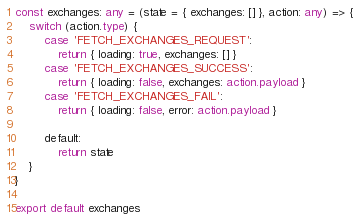Convert code to text. <code><loc_0><loc_0><loc_500><loc_500><_TypeScript_>const exchanges: any = (state = { exchanges: [] }, action: any) => {
	switch (action.type) {
		case 'FETCH_EXCHANGES_REQUEST':
			return { loading: true, exchanges: [] }
		case 'FETCH_EXCHANGES_SUCCESS':
			return { loading: false, exchanges: action.payload }
		case 'FETCH_EXCHANGES_FAIL':
			return { loading: false, error: action.payload }

		default:
			return state
	}
}

export default exchanges
</code> 